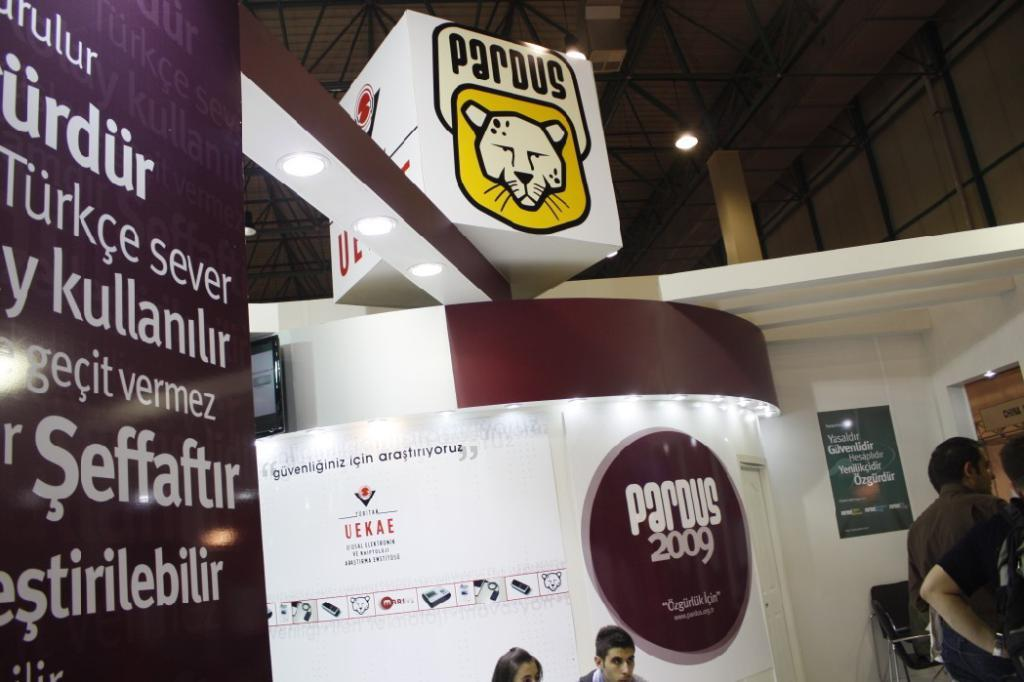<image>
Give a short and clear explanation of the subsequent image. The display at Pardus 2009 is very large. 